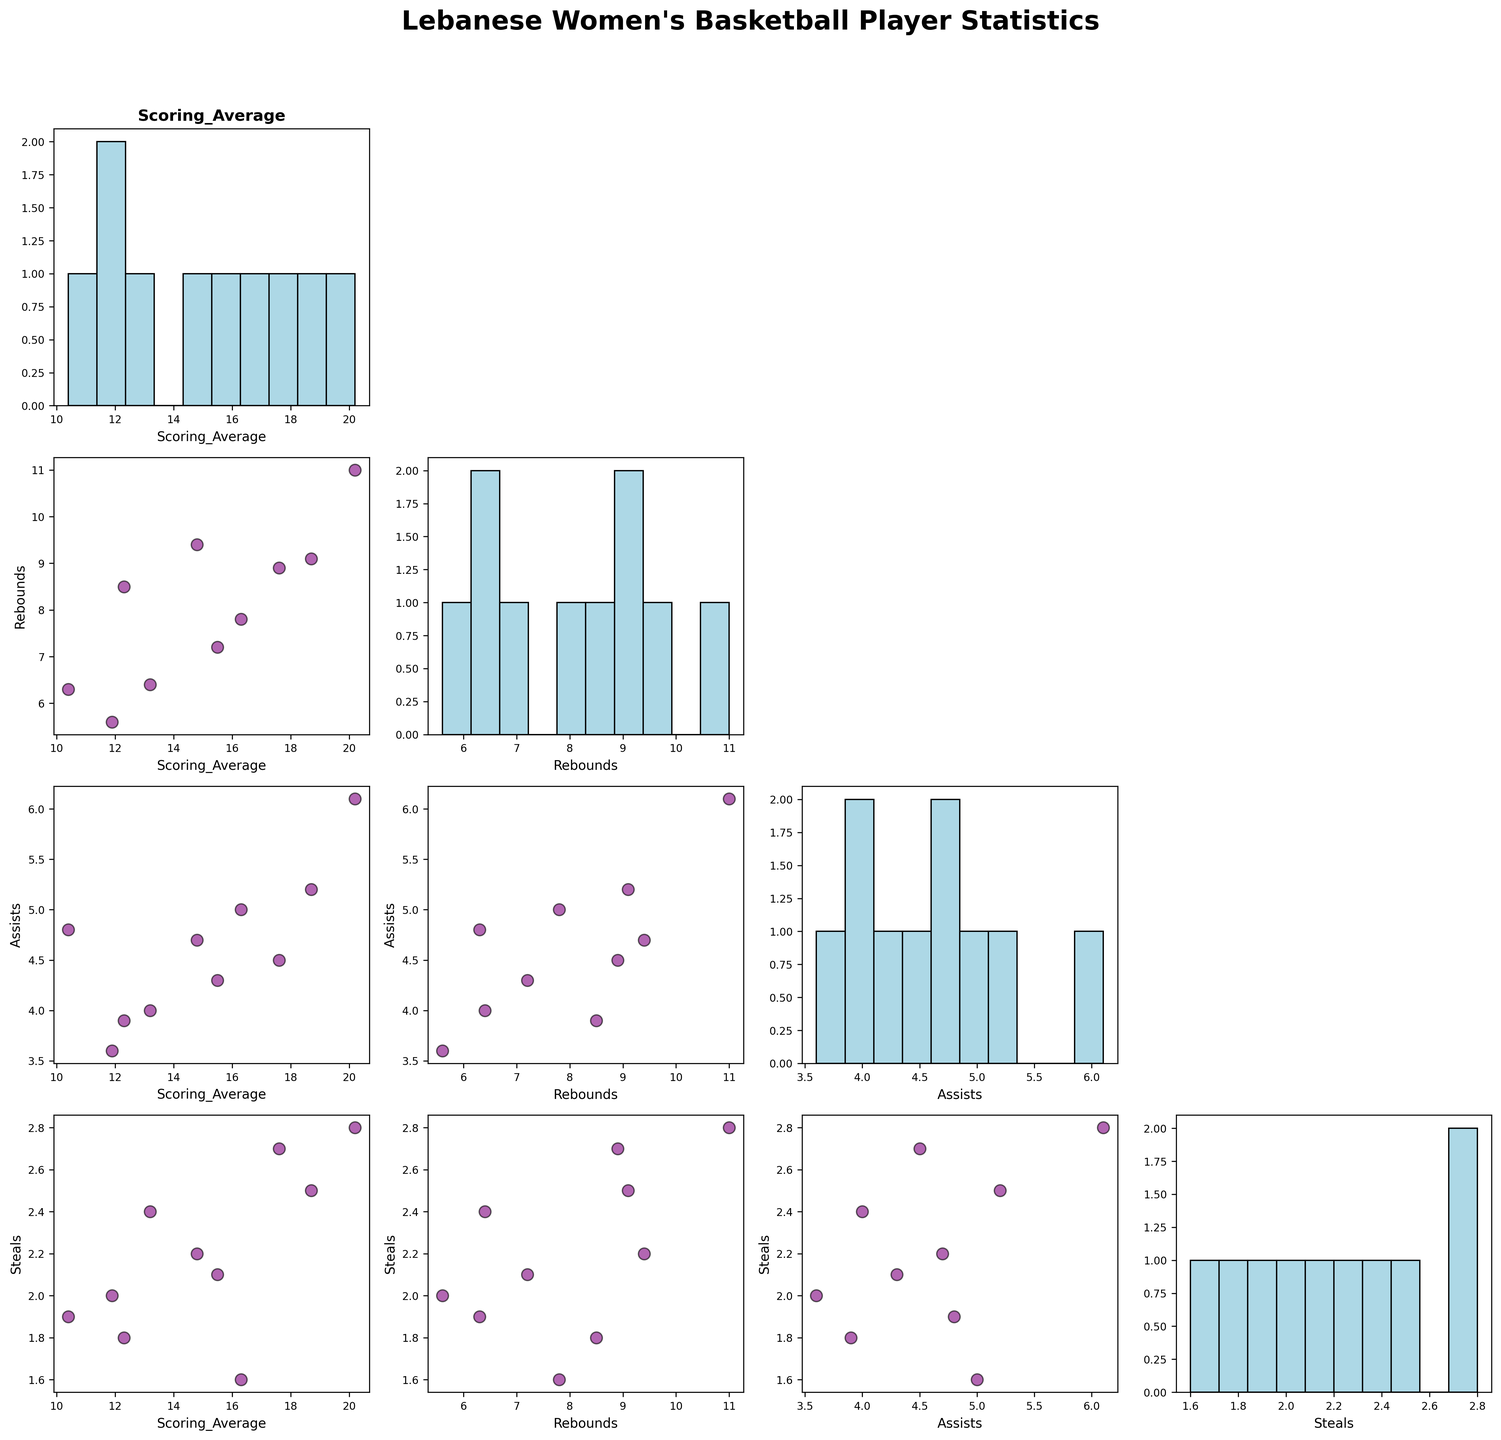Basic question: What is the title of the figure? The title of the figure is located at the top center and it reads "Lebanese Women's Basketball Player Statistics."
Answer: Lebanese Women's Basketball Player Statistics Compositional question: What is the average Scoring_Average of the players who have more than 10 Rebounds? The players with more than 10 Rebounds are Lama Moukadam with a Scoring_Average of 20.2. So the average is just 20.2.
Answer: 20.2 Comparison question: Which player has the highest number of Assists and what is that number? The highest number of Assists can be found by comparing the Assists scatter plots for all players in the SPLOM. Lama Moukadam has the highest at 6.1 Assists.
Answer: Lama Moukadam, 6.1 Chart-Type Specific question: Which variable has the most spread in its histogram? By observing the histograms on the diagonal of the SPLOM, you can see that the 'Rebounds' variable has the widest spread, indicating the largest variation in values.
Answer: Rebounds Basic question: How many variables are analyzed in the scatter plot matrix? The scatter plot matrix features four variables, visible from the rows and columns: Scoring_Average, Rebounds, Assists, and Steals.
Answer: 4 Compositional question: What is the total number of Steals by players who have a Scoring_Average greater than 15? Add up the Steals for players with a Scoring_Average greater than 15: Rebecca Azzam (2.1), Sandra Dekker (2.5), Lama Moukadam (2.8), Diana Haddad (1.6), and Lina Karam (2.7). This totals 2.1 + 2.5 + 2.8 + 1.6 + 2.7 = 11.7.
Answer: 11.7 Comparison question: Do players with higher Rebounds generally score more points? By examining the scatter plot between Rebounds and Scoring_Average, there is a slight positive trend, suggesting that players with higher Rebounds often have higher Scoring_Averages.
Answer: Yes Compositional question: What is the median number of Assists among all players? To find the median, list all Assists in ascending order: 3.6, 3.9, 4.0, 4.3, 4.5, 4.7, 4.8, 5.0, 5.2, 6.1. The median is the average of the 5th and 6th values: (4.5 + 4.7) / 2 = 4.6.
Answer: 4.6 